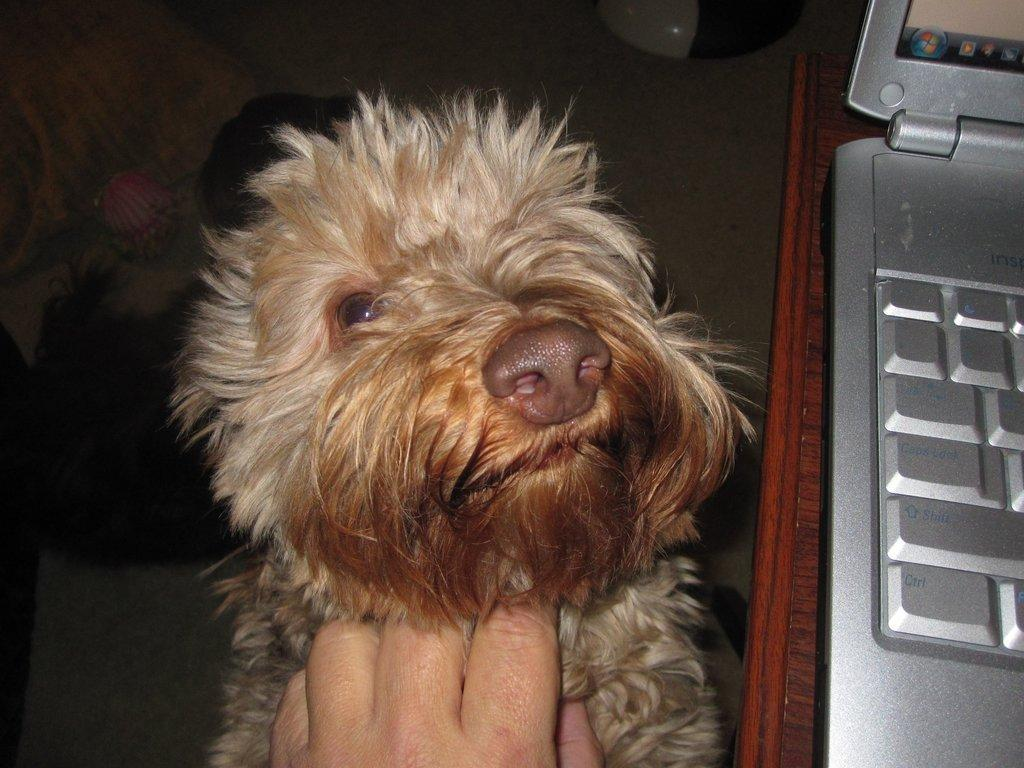What is the main subject in the center of the image? There is a dog in the center of the image. What is happening to the dog in the image? A person's hand is on the dog. What electronic device is present in the image? There is a laptop in the image. What type of surface is the laptop placed on? The laptop is placed on a wooden surface. Can you see a doll being kicked by the dog in the image? No, there is no doll or kicking action present in the image. 